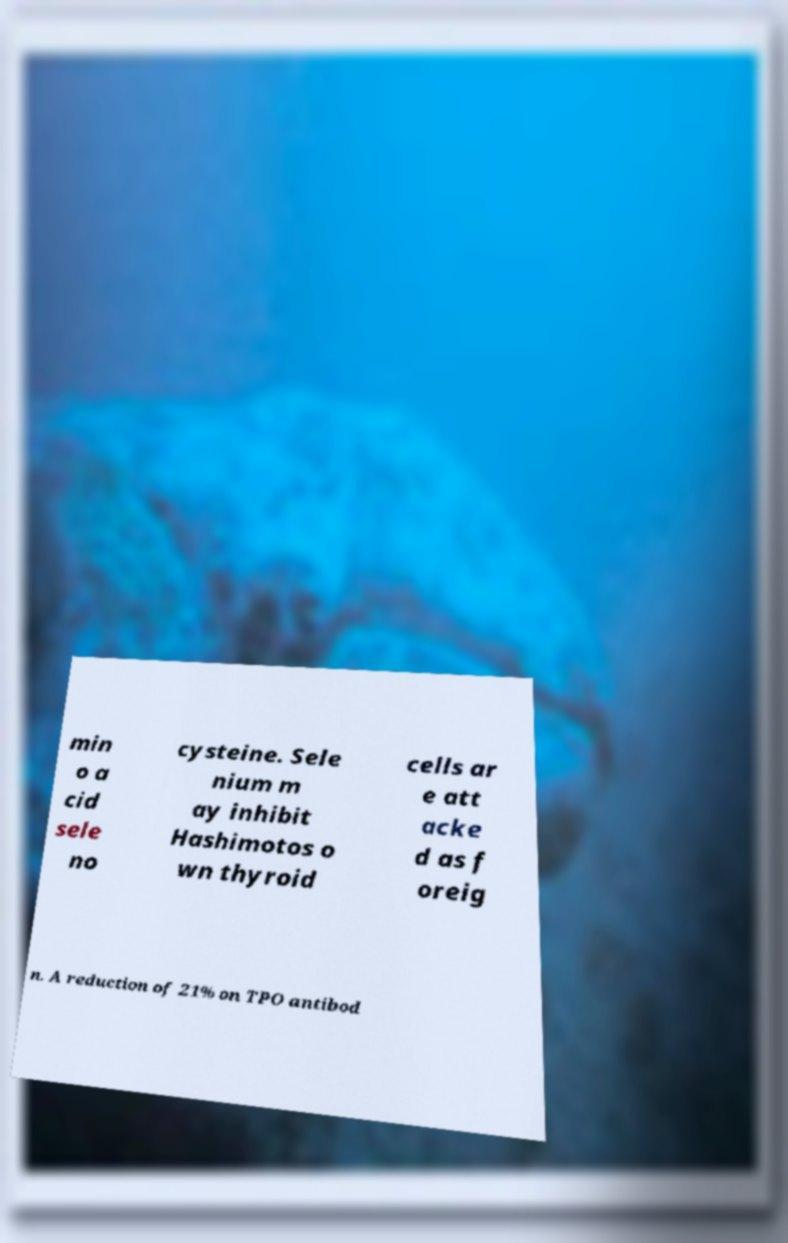For documentation purposes, I need the text within this image transcribed. Could you provide that? min o a cid sele no cysteine. Sele nium m ay inhibit Hashimotos o wn thyroid cells ar e att acke d as f oreig n. A reduction of 21% on TPO antibod 